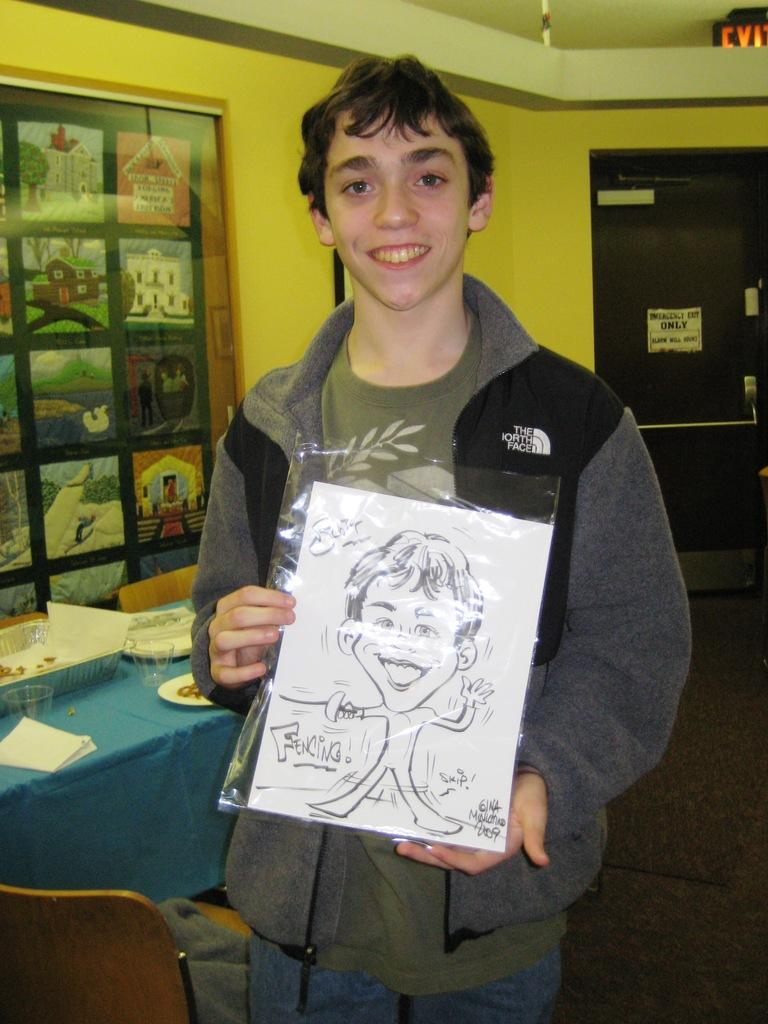Who is present in the image? There is a man in the image. What is the man doing in the image? The man is smiling and holding a paper. What can be seen in the background of the image? There are glasses, a basket, and plates on a table in the background of the image. What type of tin is the man using to hold his paper in the image? There is no tin present in the image; the man is simply holding a paper. How many aunts are visible in the image? There are no aunts present in the image; it only features a man. 